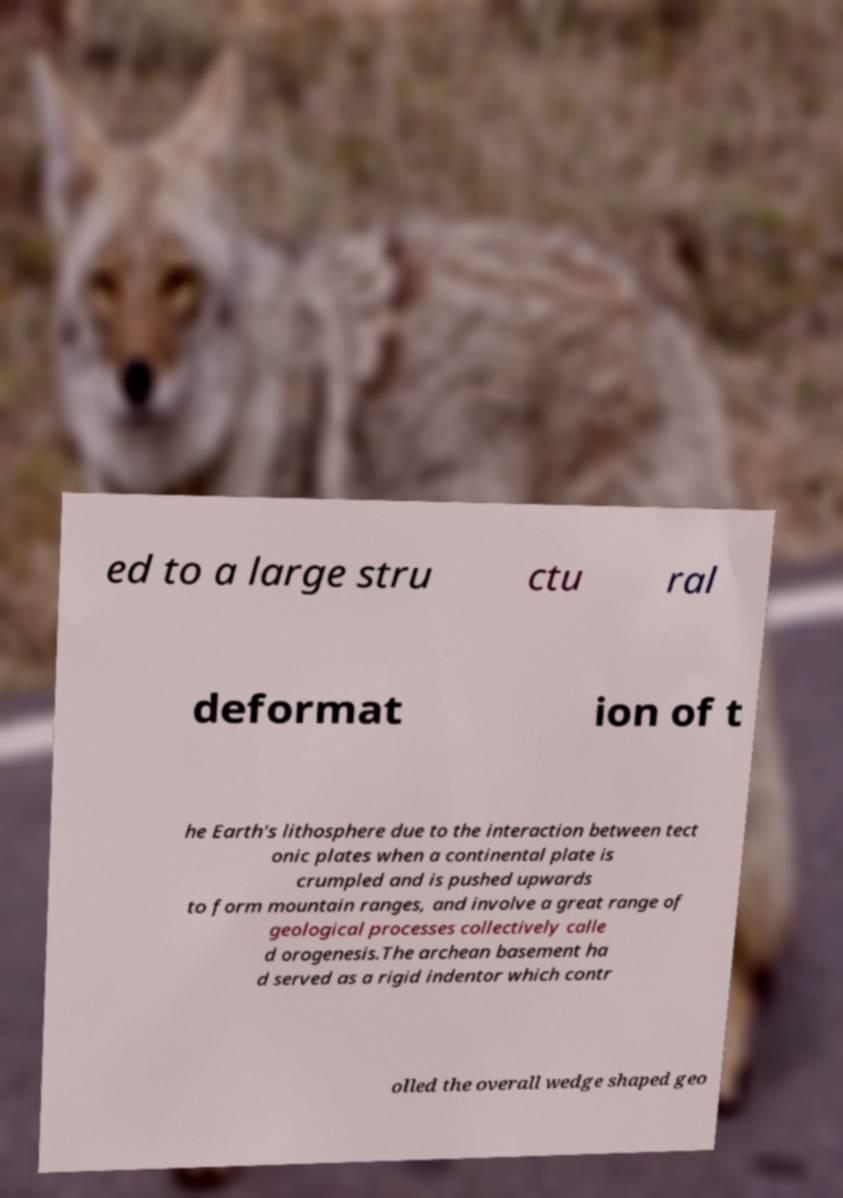For documentation purposes, I need the text within this image transcribed. Could you provide that? ed to a large stru ctu ral deformat ion of t he Earth's lithosphere due to the interaction between tect onic plates when a continental plate is crumpled and is pushed upwards to form mountain ranges, and involve a great range of geological processes collectively calle d orogenesis.The archean basement ha d served as a rigid indentor which contr olled the overall wedge shaped geo 